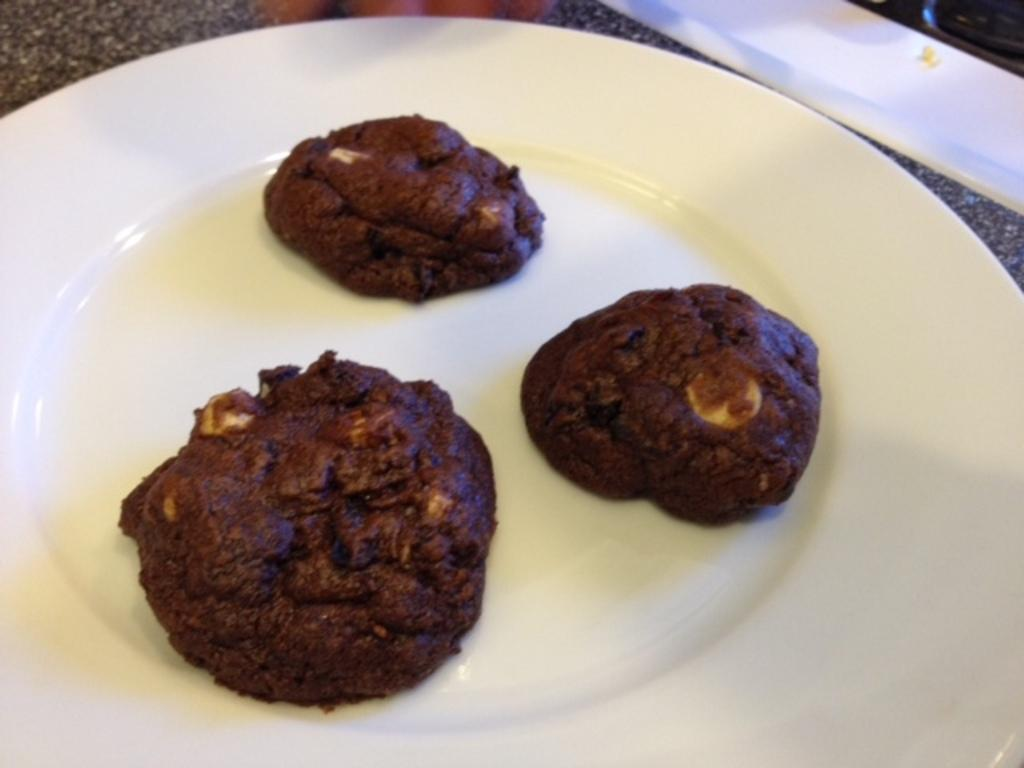What is the color of the plate in the image? The plate in the image is white. Where is the plate located in the image? The plate is on a surface in the image. What type of food can be seen on the plate? There are brown color snacks on the plate. What type of tree is growing in the school depicted in the image? There is no school or tree present in the image; it only features a white plate with brown color snacks on a surface. 